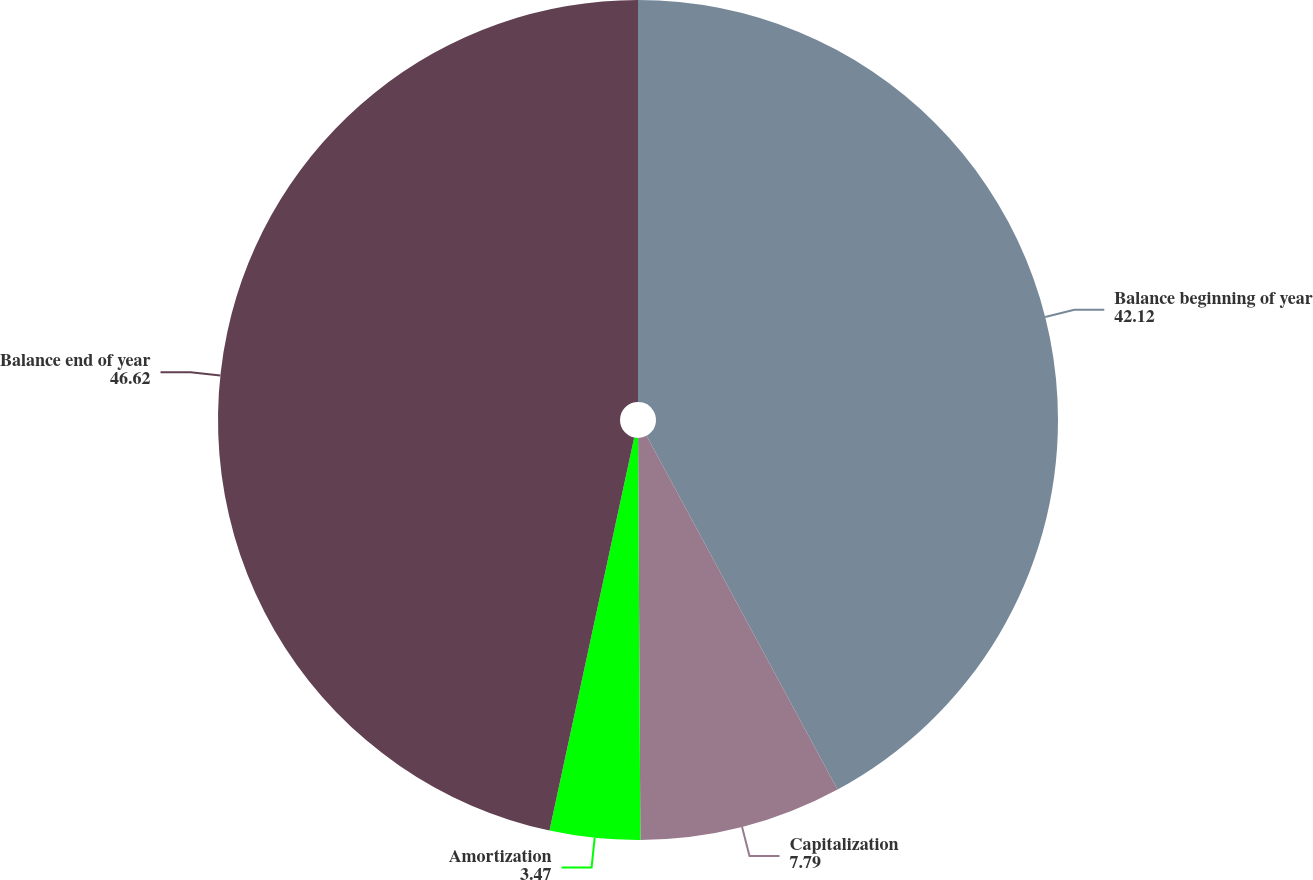Convert chart. <chart><loc_0><loc_0><loc_500><loc_500><pie_chart><fcel>Balance beginning of year<fcel>Capitalization<fcel>Amortization<fcel>Balance end of year<nl><fcel>42.12%<fcel>7.79%<fcel>3.47%<fcel>46.62%<nl></chart> 